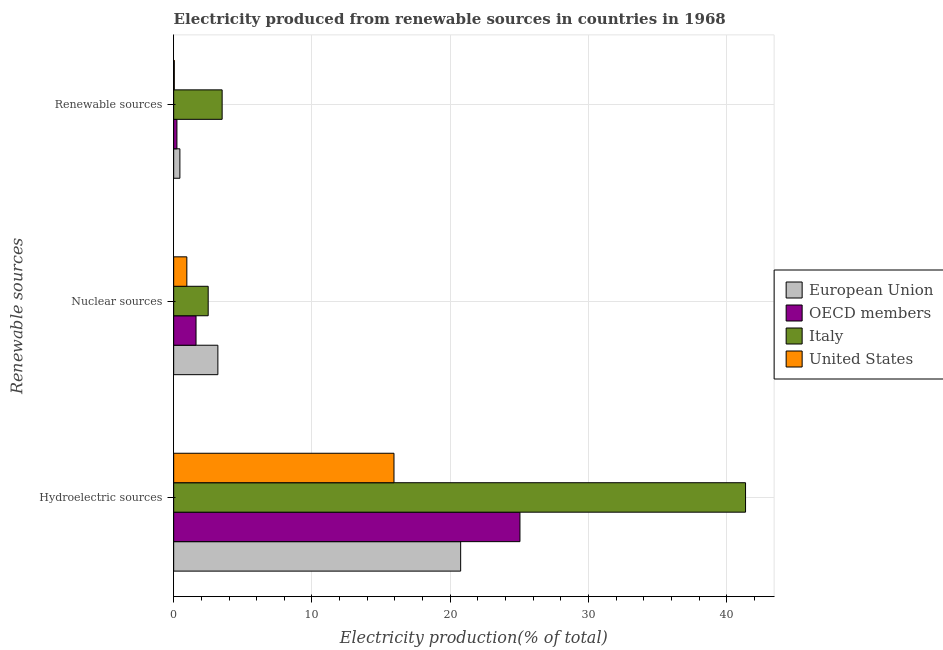How many different coloured bars are there?
Give a very brief answer. 4. How many groups of bars are there?
Provide a short and direct response. 3. Are the number of bars per tick equal to the number of legend labels?
Provide a succinct answer. Yes. Are the number of bars on each tick of the Y-axis equal?
Your answer should be compact. Yes. How many bars are there on the 2nd tick from the top?
Offer a terse response. 4. How many bars are there on the 3rd tick from the bottom?
Offer a very short reply. 4. What is the label of the 2nd group of bars from the top?
Provide a short and direct response. Nuclear sources. What is the percentage of electricity produced by renewable sources in United States?
Your answer should be compact. 0.04. Across all countries, what is the maximum percentage of electricity produced by renewable sources?
Offer a terse response. 3.5. Across all countries, what is the minimum percentage of electricity produced by hydroelectric sources?
Provide a succinct answer. 15.93. In which country was the percentage of electricity produced by hydroelectric sources maximum?
Provide a short and direct response. Italy. What is the total percentage of electricity produced by nuclear sources in the graph?
Offer a terse response. 8.26. What is the difference between the percentage of electricity produced by hydroelectric sources in OECD members and that in European Union?
Give a very brief answer. 4.29. What is the difference between the percentage of electricity produced by hydroelectric sources in Italy and the percentage of electricity produced by renewable sources in European Union?
Ensure brevity in your answer.  40.9. What is the average percentage of electricity produced by renewable sources per country?
Your answer should be compact. 1.06. What is the difference between the percentage of electricity produced by nuclear sources and percentage of electricity produced by renewable sources in European Union?
Your answer should be compact. 2.75. In how many countries, is the percentage of electricity produced by nuclear sources greater than 14 %?
Ensure brevity in your answer.  0. What is the ratio of the percentage of electricity produced by nuclear sources in United States to that in European Union?
Provide a short and direct response. 0.3. Is the difference between the percentage of electricity produced by renewable sources in Italy and European Union greater than the difference between the percentage of electricity produced by hydroelectric sources in Italy and European Union?
Keep it short and to the point. No. What is the difference between the highest and the second highest percentage of electricity produced by nuclear sources?
Make the answer very short. 0.7. What is the difference between the highest and the lowest percentage of electricity produced by nuclear sources?
Your response must be concise. 2.24. In how many countries, is the percentage of electricity produced by renewable sources greater than the average percentage of electricity produced by renewable sources taken over all countries?
Your answer should be very brief. 1. What does the 2nd bar from the top in Renewable sources represents?
Your answer should be compact. Italy. What does the 2nd bar from the bottom in Nuclear sources represents?
Keep it short and to the point. OECD members. How many bars are there?
Your answer should be very brief. 12. Are all the bars in the graph horizontal?
Keep it short and to the point. Yes. How many countries are there in the graph?
Your answer should be compact. 4. What is the difference between two consecutive major ticks on the X-axis?
Give a very brief answer. 10. Does the graph contain any zero values?
Keep it short and to the point. No. Where does the legend appear in the graph?
Offer a terse response. Center right. What is the title of the graph?
Ensure brevity in your answer.  Electricity produced from renewable sources in countries in 1968. Does "Latvia" appear as one of the legend labels in the graph?
Your answer should be very brief. No. What is the label or title of the Y-axis?
Keep it short and to the point. Renewable sources. What is the Electricity production(% of total) in European Union in Hydroelectric sources?
Keep it short and to the point. 20.75. What is the Electricity production(% of total) in OECD members in Hydroelectric sources?
Give a very brief answer. 25.04. What is the Electricity production(% of total) in Italy in Hydroelectric sources?
Your answer should be very brief. 41.35. What is the Electricity production(% of total) in United States in Hydroelectric sources?
Make the answer very short. 15.93. What is the Electricity production(% of total) of European Union in Nuclear sources?
Offer a very short reply. 3.2. What is the Electricity production(% of total) in OECD members in Nuclear sources?
Your answer should be very brief. 1.62. What is the Electricity production(% of total) of Italy in Nuclear sources?
Make the answer very short. 2.5. What is the Electricity production(% of total) of United States in Nuclear sources?
Offer a terse response. 0.95. What is the Electricity production(% of total) of European Union in Renewable sources?
Your answer should be compact. 0.45. What is the Electricity production(% of total) in OECD members in Renewable sources?
Provide a short and direct response. 0.23. What is the Electricity production(% of total) in Italy in Renewable sources?
Offer a terse response. 3.5. What is the Electricity production(% of total) of United States in Renewable sources?
Provide a succinct answer. 0.04. Across all Renewable sources, what is the maximum Electricity production(% of total) of European Union?
Provide a succinct answer. 20.75. Across all Renewable sources, what is the maximum Electricity production(% of total) of OECD members?
Provide a succinct answer. 25.04. Across all Renewable sources, what is the maximum Electricity production(% of total) in Italy?
Your answer should be very brief. 41.35. Across all Renewable sources, what is the maximum Electricity production(% of total) of United States?
Give a very brief answer. 15.93. Across all Renewable sources, what is the minimum Electricity production(% of total) of European Union?
Offer a terse response. 0.45. Across all Renewable sources, what is the minimum Electricity production(% of total) of OECD members?
Ensure brevity in your answer.  0.23. Across all Renewable sources, what is the minimum Electricity production(% of total) in Italy?
Your answer should be very brief. 2.5. Across all Renewable sources, what is the minimum Electricity production(% of total) in United States?
Your answer should be very brief. 0.04. What is the total Electricity production(% of total) in European Union in the graph?
Ensure brevity in your answer.  24.4. What is the total Electricity production(% of total) of OECD members in the graph?
Offer a very short reply. 26.89. What is the total Electricity production(% of total) in Italy in the graph?
Your answer should be very brief. 47.35. What is the total Electricity production(% of total) of United States in the graph?
Provide a succinct answer. 16.93. What is the difference between the Electricity production(% of total) in European Union in Hydroelectric sources and that in Nuclear sources?
Provide a short and direct response. 17.56. What is the difference between the Electricity production(% of total) of OECD members in Hydroelectric sources and that in Nuclear sources?
Provide a succinct answer. 23.42. What is the difference between the Electricity production(% of total) in Italy in Hydroelectric sources and that in Nuclear sources?
Ensure brevity in your answer.  38.85. What is the difference between the Electricity production(% of total) in United States in Hydroelectric sources and that in Nuclear sources?
Your answer should be compact. 14.98. What is the difference between the Electricity production(% of total) of European Union in Hydroelectric sources and that in Renewable sources?
Provide a succinct answer. 20.3. What is the difference between the Electricity production(% of total) in OECD members in Hydroelectric sources and that in Renewable sources?
Offer a terse response. 24.8. What is the difference between the Electricity production(% of total) in Italy in Hydroelectric sources and that in Renewable sources?
Your answer should be compact. 37.84. What is the difference between the Electricity production(% of total) in United States in Hydroelectric sources and that in Renewable sources?
Provide a short and direct response. 15.88. What is the difference between the Electricity production(% of total) of European Union in Nuclear sources and that in Renewable sources?
Ensure brevity in your answer.  2.75. What is the difference between the Electricity production(% of total) of OECD members in Nuclear sources and that in Renewable sources?
Your answer should be compact. 1.38. What is the difference between the Electricity production(% of total) in Italy in Nuclear sources and that in Renewable sources?
Offer a terse response. -1.01. What is the difference between the Electricity production(% of total) in United States in Nuclear sources and that in Renewable sources?
Offer a terse response. 0.91. What is the difference between the Electricity production(% of total) of European Union in Hydroelectric sources and the Electricity production(% of total) of OECD members in Nuclear sources?
Your response must be concise. 19.13. What is the difference between the Electricity production(% of total) in European Union in Hydroelectric sources and the Electricity production(% of total) in Italy in Nuclear sources?
Offer a terse response. 18.26. What is the difference between the Electricity production(% of total) in European Union in Hydroelectric sources and the Electricity production(% of total) in United States in Nuclear sources?
Offer a terse response. 19.8. What is the difference between the Electricity production(% of total) in OECD members in Hydroelectric sources and the Electricity production(% of total) in Italy in Nuclear sources?
Offer a terse response. 22.54. What is the difference between the Electricity production(% of total) in OECD members in Hydroelectric sources and the Electricity production(% of total) in United States in Nuclear sources?
Provide a short and direct response. 24.09. What is the difference between the Electricity production(% of total) in Italy in Hydroelectric sources and the Electricity production(% of total) in United States in Nuclear sources?
Keep it short and to the point. 40.4. What is the difference between the Electricity production(% of total) in European Union in Hydroelectric sources and the Electricity production(% of total) in OECD members in Renewable sources?
Provide a succinct answer. 20.52. What is the difference between the Electricity production(% of total) in European Union in Hydroelectric sources and the Electricity production(% of total) in Italy in Renewable sources?
Provide a succinct answer. 17.25. What is the difference between the Electricity production(% of total) in European Union in Hydroelectric sources and the Electricity production(% of total) in United States in Renewable sources?
Offer a terse response. 20.71. What is the difference between the Electricity production(% of total) in OECD members in Hydroelectric sources and the Electricity production(% of total) in Italy in Renewable sources?
Offer a terse response. 21.53. What is the difference between the Electricity production(% of total) in OECD members in Hydroelectric sources and the Electricity production(% of total) in United States in Renewable sources?
Offer a terse response. 24.99. What is the difference between the Electricity production(% of total) in Italy in Hydroelectric sources and the Electricity production(% of total) in United States in Renewable sources?
Your response must be concise. 41.3. What is the difference between the Electricity production(% of total) in European Union in Nuclear sources and the Electricity production(% of total) in OECD members in Renewable sources?
Provide a succinct answer. 2.96. What is the difference between the Electricity production(% of total) in European Union in Nuclear sources and the Electricity production(% of total) in Italy in Renewable sources?
Offer a terse response. -0.31. What is the difference between the Electricity production(% of total) of European Union in Nuclear sources and the Electricity production(% of total) of United States in Renewable sources?
Provide a succinct answer. 3.15. What is the difference between the Electricity production(% of total) of OECD members in Nuclear sources and the Electricity production(% of total) of Italy in Renewable sources?
Offer a very short reply. -1.89. What is the difference between the Electricity production(% of total) in OECD members in Nuclear sources and the Electricity production(% of total) in United States in Renewable sources?
Your answer should be compact. 1.57. What is the difference between the Electricity production(% of total) in Italy in Nuclear sources and the Electricity production(% of total) in United States in Renewable sources?
Your answer should be very brief. 2.45. What is the average Electricity production(% of total) of European Union per Renewable sources?
Your answer should be very brief. 8.13. What is the average Electricity production(% of total) of OECD members per Renewable sources?
Your answer should be very brief. 8.96. What is the average Electricity production(% of total) in Italy per Renewable sources?
Your answer should be very brief. 15.78. What is the average Electricity production(% of total) of United States per Renewable sources?
Keep it short and to the point. 5.64. What is the difference between the Electricity production(% of total) in European Union and Electricity production(% of total) in OECD members in Hydroelectric sources?
Keep it short and to the point. -4.29. What is the difference between the Electricity production(% of total) of European Union and Electricity production(% of total) of Italy in Hydroelectric sources?
Provide a succinct answer. -20.6. What is the difference between the Electricity production(% of total) in European Union and Electricity production(% of total) in United States in Hydroelectric sources?
Make the answer very short. 4.82. What is the difference between the Electricity production(% of total) in OECD members and Electricity production(% of total) in Italy in Hydroelectric sources?
Ensure brevity in your answer.  -16.31. What is the difference between the Electricity production(% of total) of OECD members and Electricity production(% of total) of United States in Hydroelectric sources?
Make the answer very short. 9.11. What is the difference between the Electricity production(% of total) in Italy and Electricity production(% of total) in United States in Hydroelectric sources?
Keep it short and to the point. 25.42. What is the difference between the Electricity production(% of total) in European Union and Electricity production(% of total) in OECD members in Nuclear sources?
Keep it short and to the point. 1.58. What is the difference between the Electricity production(% of total) of European Union and Electricity production(% of total) of Italy in Nuclear sources?
Provide a short and direct response. 0.7. What is the difference between the Electricity production(% of total) of European Union and Electricity production(% of total) of United States in Nuclear sources?
Provide a short and direct response. 2.24. What is the difference between the Electricity production(% of total) of OECD members and Electricity production(% of total) of Italy in Nuclear sources?
Make the answer very short. -0.88. What is the difference between the Electricity production(% of total) in OECD members and Electricity production(% of total) in United States in Nuclear sources?
Ensure brevity in your answer.  0.66. What is the difference between the Electricity production(% of total) of Italy and Electricity production(% of total) of United States in Nuclear sources?
Offer a terse response. 1.54. What is the difference between the Electricity production(% of total) in European Union and Electricity production(% of total) in OECD members in Renewable sources?
Keep it short and to the point. 0.21. What is the difference between the Electricity production(% of total) of European Union and Electricity production(% of total) of Italy in Renewable sources?
Offer a terse response. -3.06. What is the difference between the Electricity production(% of total) of European Union and Electricity production(% of total) of United States in Renewable sources?
Offer a terse response. 0.4. What is the difference between the Electricity production(% of total) in OECD members and Electricity production(% of total) in Italy in Renewable sources?
Offer a very short reply. -3.27. What is the difference between the Electricity production(% of total) of OECD members and Electricity production(% of total) of United States in Renewable sources?
Keep it short and to the point. 0.19. What is the difference between the Electricity production(% of total) in Italy and Electricity production(% of total) in United States in Renewable sources?
Provide a short and direct response. 3.46. What is the ratio of the Electricity production(% of total) of European Union in Hydroelectric sources to that in Nuclear sources?
Give a very brief answer. 6.49. What is the ratio of the Electricity production(% of total) in OECD members in Hydroelectric sources to that in Nuclear sources?
Give a very brief answer. 15.48. What is the ratio of the Electricity production(% of total) of Italy in Hydroelectric sources to that in Nuclear sources?
Provide a succinct answer. 16.57. What is the ratio of the Electricity production(% of total) of United States in Hydroelectric sources to that in Nuclear sources?
Ensure brevity in your answer.  16.73. What is the ratio of the Electricity production(% of total) in European Union in Hydroelectric sources to that in Renewable sources?
Your answer should be very brief. 46.18. What is the ratio of the Electricity production(% of total) of OECD members in Hydroelectric sources to that in Renewable sources?
Your answer should be compact. 106.6. What is the ratio of the Electricity production(% of total) in Italy in Hydroelectric sources to that in Renewable sources?
Keep it short and to the point. 11.8. What is the ratio of the Electricity production(% of total) in United States in Hydroelectric sources to that in Renewable sources?
Your answer should be compact. 356.47. What is the ratio of the Electricity production(% of total) in European Union in Nuclear sources to that in Renewable sources?
Ensure brevity in your answer.  7.11. What is the ratio of the Electricity production(% of total) of OECD members in Nuclear sources to that in Renewable sources?
Your answer should be very brief. 6.88. What is the ratio of the Electricity production(% of total) in Italy in Nuclear sources to that in Renewable sources?
Keep it short and to the point. 0.71. What is the ratio of the Electricity production(% of total) of United States in Nuclear sources to that in Renewable sources?
Offer a terse response. 21.31. What is the difference between the highest and the second highest Electricity production(% of total) of European Union?
Give a very brief answer. 17.56. What is the difference between the highest and the second highest Electricity production(% of total) in OECD members?
Ensure brevity in your answer.  23.42. What is the difference between the highest and the second highest Electricity production(% of total) in Italy?
Your answer should be very brief. 37.84. What is the difference between the highest and the second highest Electricity production(% of total) of United States?
Give a very brief answer. 14.98. What is the difference between the highest and the lowest Electricity production(% of total) in European Union?
Offer a very short reply. 20.3. What is the difference between the highest and the lowest Electricity production(% of total) in OECD members?
Provide a short and direct response. 24.8. What is the difference between the highest and the lowest Electricity production(% of total) in Italy?
Your answer should be compact. 38.85. What is the difference between the highest and the lowest Electricity production(% of total) of United States?
Make the answer very short. 15.88. 